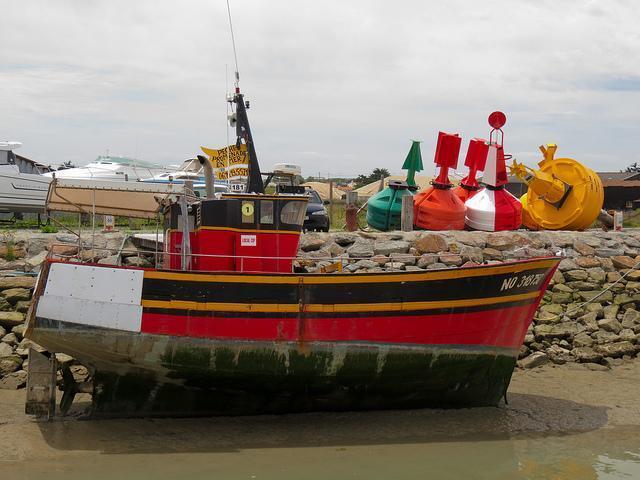How many buoy's are in view?
Give a very brief answer. 5. How many boats are visible?
Give a very brief answer. 2. 